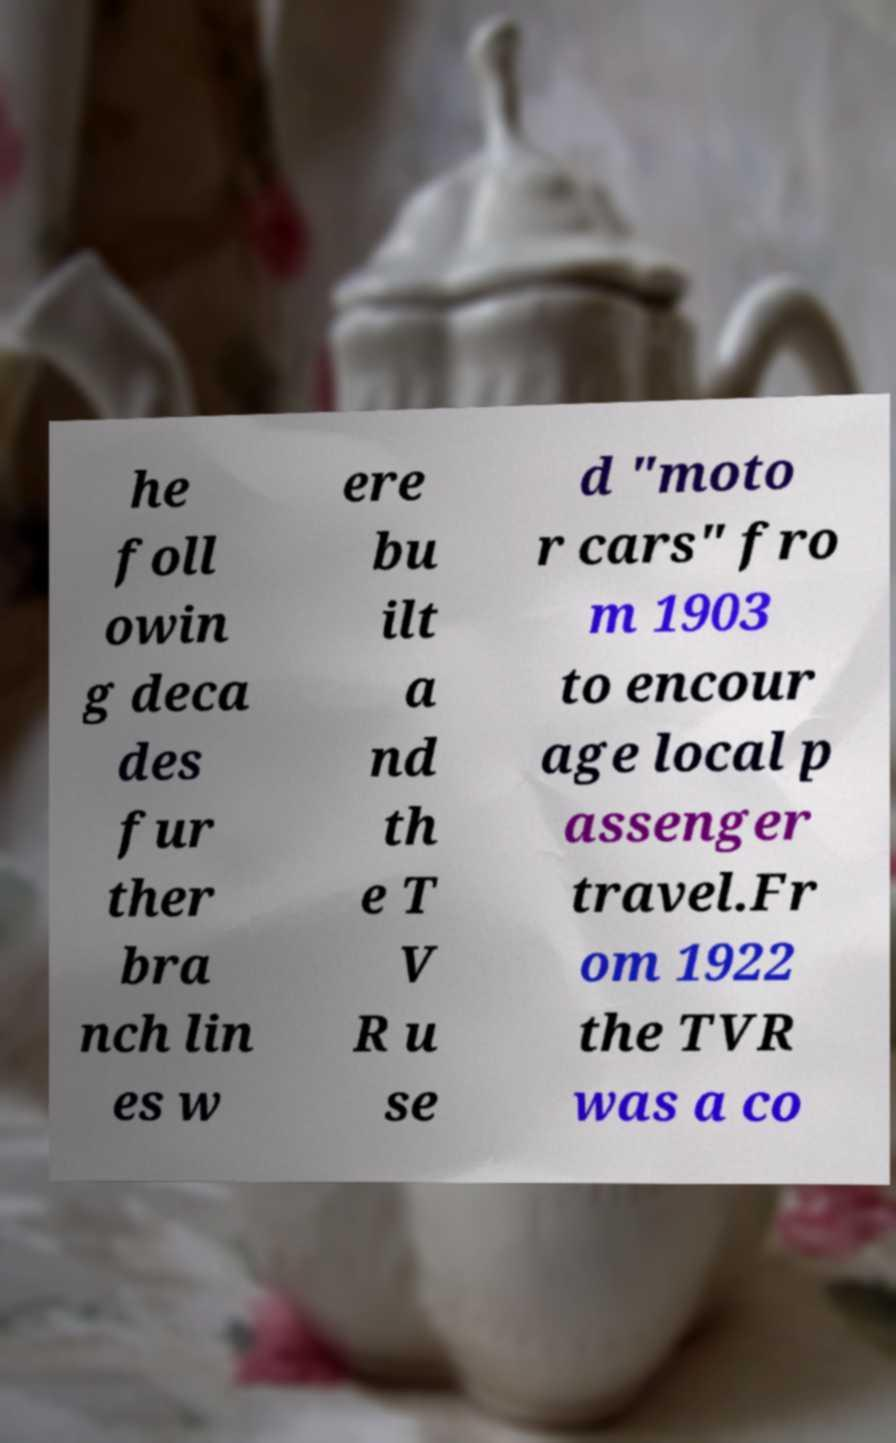I need the written content from this picture converted into text. Can you do that? he foll owin g deca des fur ther bra nch lin es w ere bu ilt a nd th e T V R u se d "moto r cars" fro m 1903 to encour age local p assenger travel.Fr om 1922 the TVR was a co 